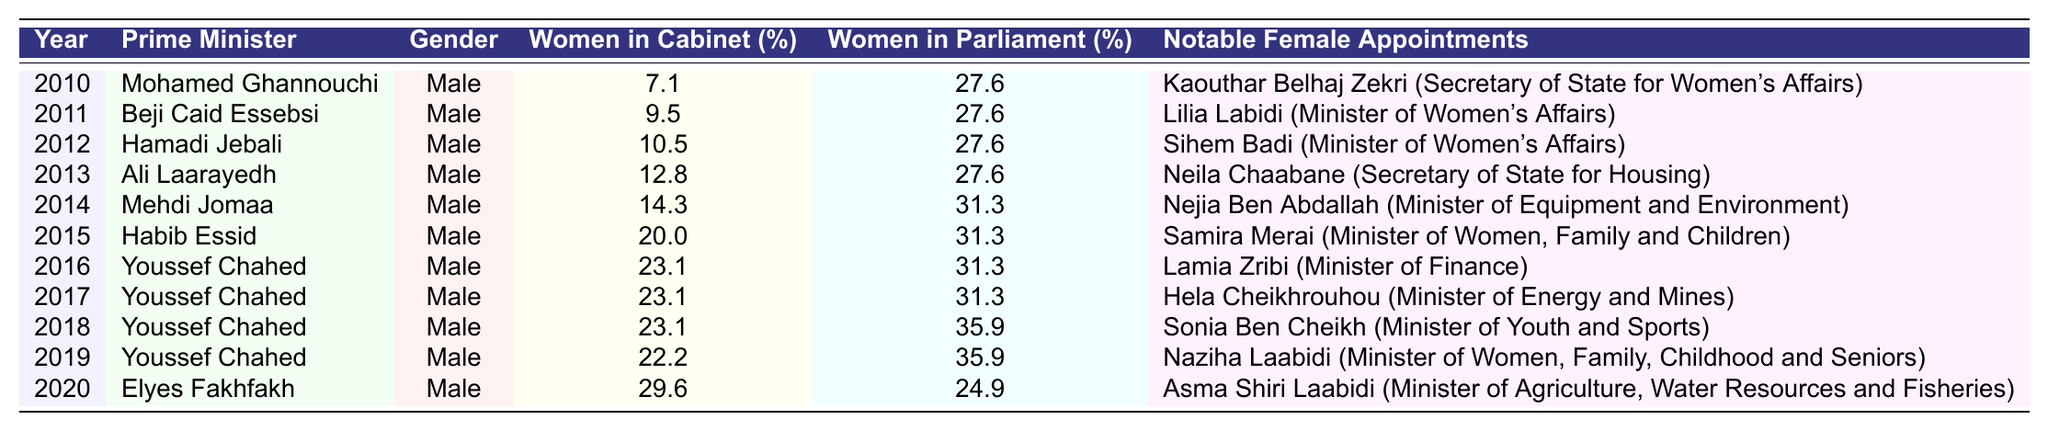What was the percentage of women in the Cabinet in 2015? The table shows that in 2015, the percentage of women in the Cabinet was 20.0%.
Answer: 20.0% Who was the Prime Minister in 2018? According to the table, the Prime Minister in 2018 was Youssef Chahed.
Answer: Youssef Chahed What notable female appointment was made in 2014? The notable female appointment in 2014 was Nejia Ben Abdallah, who served as the Minister of Equipment and Environment.
Answer: Nejia Ben Abdallah What was the trend in the percentage of women in the Cabinet from 2010 to 2020? The percentage of women in the Cabinet increased from 7.1% in 2010 to 29.6% in 2020, indicating a general upward trend over the years.
Answer: Increasing What was the average percentage of women in Parliament from 2010 to 2020? To find the average, add the percentages of women in Parliament for each year: (27.6 + 27.6 + 27.6 + 27.6 + 31.3 + 31.3 + 31.3 + 35.9 + 35.9 + 24.9) =  314.3, then divide by 11 years, which equals 314.3 / 11 ≈ 28.57%.
Answer: 28.57% Did any female serve as Prime Minister during the years 2010 to 2020? According to the table, there were no female Prime Ministers from 2010 to 2020.
Answer: No Which year had the highest percentage of women in the Cabinet? In 2020, the percentage of women in the Cabinet reached 29.6%, which was the highest in the table for the years listed.
Answer: 2020 Calculate the difference in the percentage of women in Cabinet between 2010 and 2020. The percentage of women in Cabinet was 7.1% in 2010 and 29.6% in 2020. The difference is 29.6 - 7.1 = 22.5%.
Answer: 22.5% Was there an increase in the percentage of women in Parliament from 2019 to 2020? In 2019, the percentage of women in Parliament was 35.9%, while in 2020 it dropped to 24.9%. Therefore, there was a decrease, not an increase.
Answer: No What notable female appointments were made in the year 2019? The notable female appointment in 2019 was Naziha Laabidi, who served as the Minister of Women, Family, Childhood and Seniors.
Answer: Naziha Laabidi 